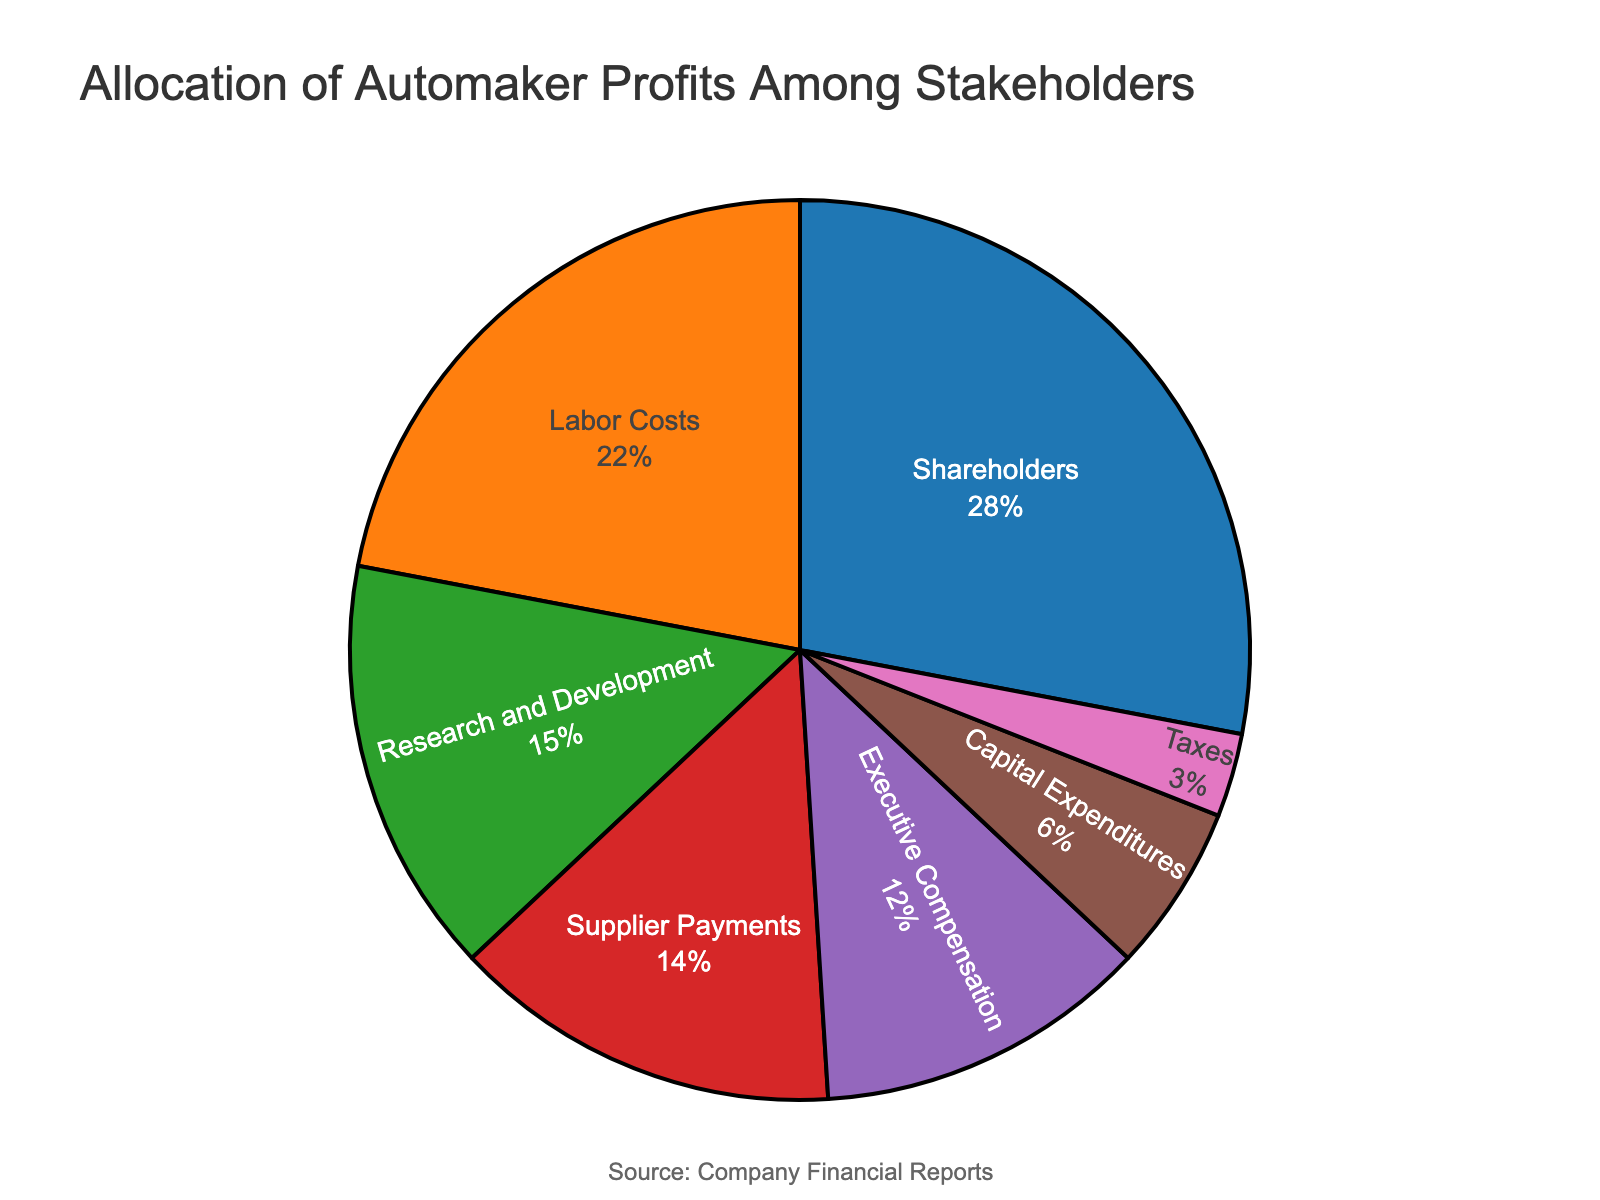Which stakeholder receives the largest percentage of automaker profits? From the pie chart, the largest slice represents the stakeholder with the highest percentage. The "Shareholders" slice is the largest.
Answer: Shareholders What's the combined percentage of profits allocated to Research and Development and Capital Expenditures? To find the combined percentage, add the values for Research and Development (15%) and Capital Expenditures (6%). 15% + 6% = 21%
Answer: 21% Which stakeholder receives a greater percentage of profits: Labor Costs or Supplier Payments? The pie chart shows that Labor Costs receive 22% and Supplier Payments receive 14%. Since 22% is greater than 14%, Labor Costs receive a greater percentage.
Answer: Labor Costs What is the difference in percentage between Executive Compensation and Taxes? Subtract the percentage allocated to Taxes (3%) from the percentage allocated to Executive Compensation (12%). 12% - 3% = 9%
Answer: 9% How much more percentage of profits do Shareholders receive compared to Labor Costs? Subtract the percentage for Labor Costs (22%) from the percentage for Shareholders (28%). 28% - 22% = 6%
Answer: 6% Which stakeholders together receive a smaller percentage than Shareholders alone? Add the percentages for stakeholders and compare: Executive Compensation (12%), Research and Development (15%), Supplier Payments (14%), Capital Expenditures (6%), Taxes (3%). The only combination that meets this is Executive Compensation (12%) and either Research and Development (15%), Supplier Payments (14%), or Capital Expenditures (6%) along with Taxes (3%). All other combinations exceed 28%.
Answer: All except Labor Costs What percentage of profits is allocated to stakeholders other than Shareholders and Labor Costs? Subtract the percentages for Shareholders (28%) and Labor Costs (22%) from 100%. 100% - (28% + 22%) = 50%
Answer: 50% Among the stakeholders with allocations below 10%, which one receives the smallest share of the profits? From the pie chart, Taxes have the lowest stake at 3%.
Answer: Taxes What is the total percentage allocation for Supplier Payments, Capital Expenditures, and Taxes combined? Add the percentages for Supplier Payments (14%), Capital Expenditures (6%), and Taxes (3%). 14% + 6% + 3% = 23%
Answer: 23% What is the average percentage allocation across all stakeholders? To find the average, add all the percentages and divide by the number of stakeholders. (28% + 12% + 15% + 22% + 14% + 6% + 3%) / 7 = 100% / 7 ≈ 14.29%
Answer: ~14.29% 